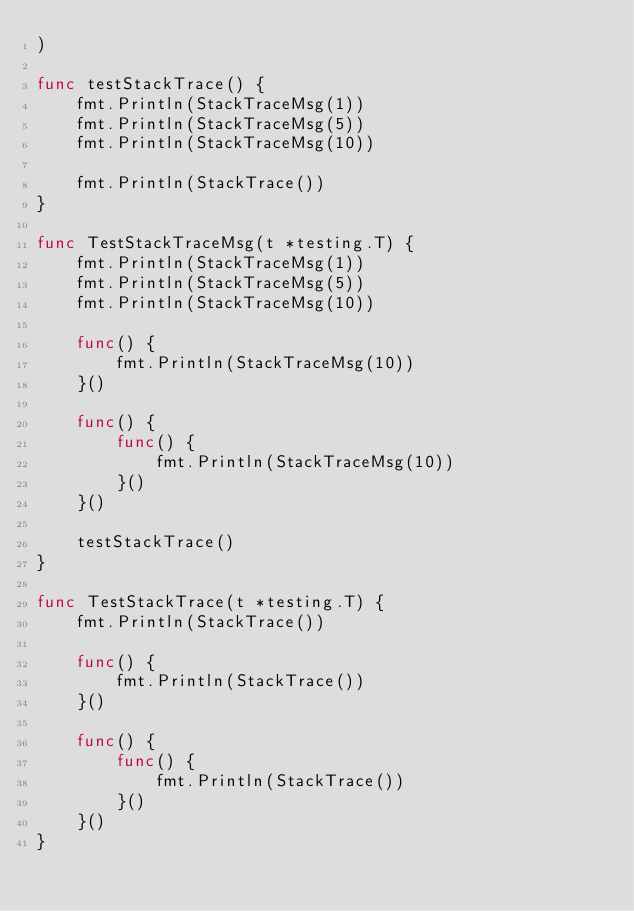Convert code to text. <code><loc_0><loc_0><loc_500><loc_500><_Go_>)

func testStackTrace() {
	fmt.Println(StackTraceMsg(1))
	fmt.Println(StackTraceMsg(5))
	fmt.Println(StackTraceMsg(10))

	fmt.Println(StackTrace())
}

func TestStackTraceMsg(t *testing.T) {
	fmt.Println(StackTraceMsg(1))
	fmt.Println(StackTraceMsg(5))
	fmt.Println(StackTraceMsg(10))

	func() {
		fmt.Println(StackTraceMsg(10))
	}()

	func() {
		func() {
			fmt.Println(StackTraceMsg(10))
		}()
	}()

	testStackTrace()
}

func TestStackTrace(t *testing.T) {
	fmt.Println(StackTrace())

	func() {
		fmt.Println(StackTrace())
	}()

	func() {
		func() {
			fmt.Println(StackTrace())
		}()
	}()
}
</code> 